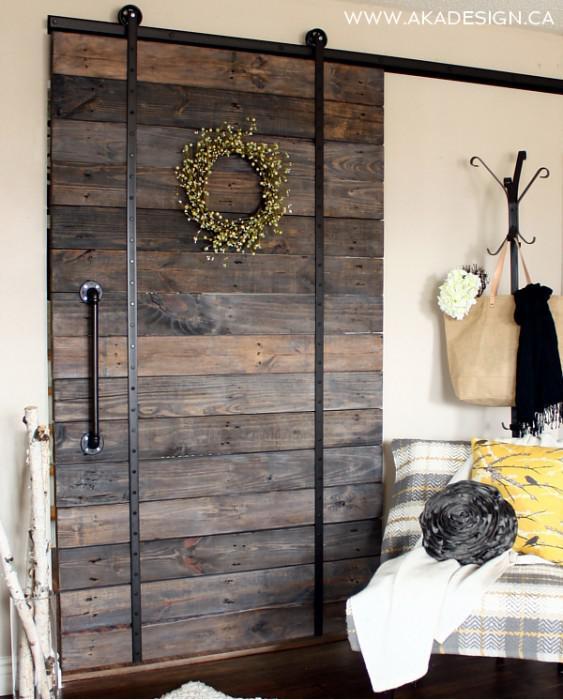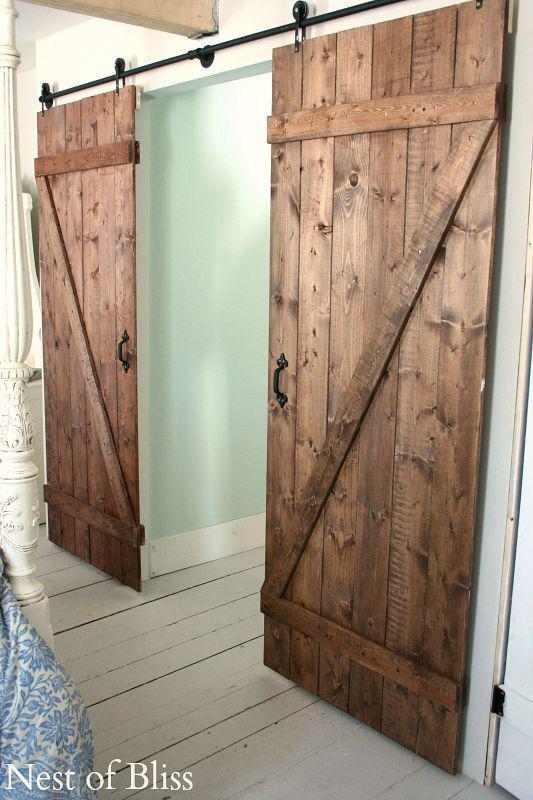The first image is the image on the left, the second image is the image on the right. For the images displayed, is the sentence "There are a total of four windows to the outdoors." factually correct? Answer yes or no. No. 